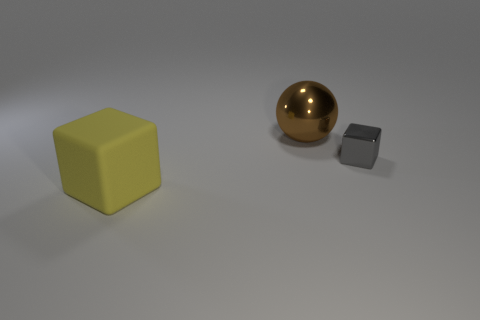Add 1 big yellow rubber blocks. How many objects exist? 4 Subtract all balls. How many objects are left? 2 Subtract all large spheres. Subtract all red rubber cylinders. How many objects are left? 2 Add 1 big brown things. How many big brown things are left? 2 Add 2 gray shiny blocks. How many gray shiny blocks exist? 3 Subtract 0 gray balls. How many objects are left? 3 